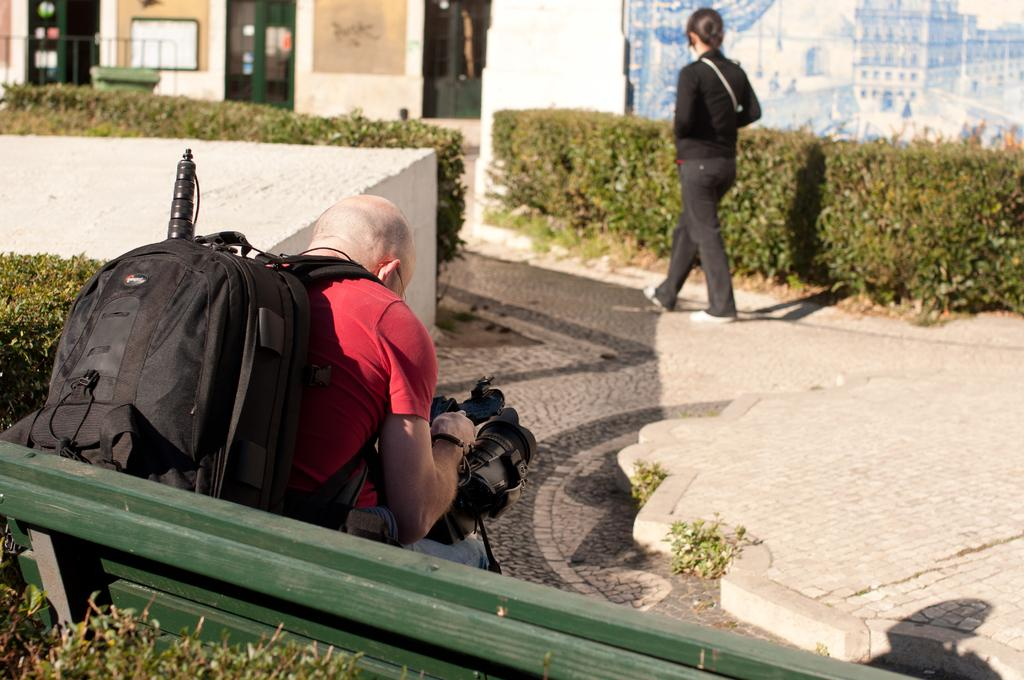What is the man in the image doing? The man is sitting on a bench in the image. What is the man wearing that might be used for carrying items? The man is wearing a bag in the image. What is the man holding in his hand? The man is holding a camera in the image. What can be seen in the background of the image? In the background, there is a woman walking on a road, small trees, a building, and a pole. What type of ticket does the man have for the soda in the image? There is no ticket or soda present in the image. 